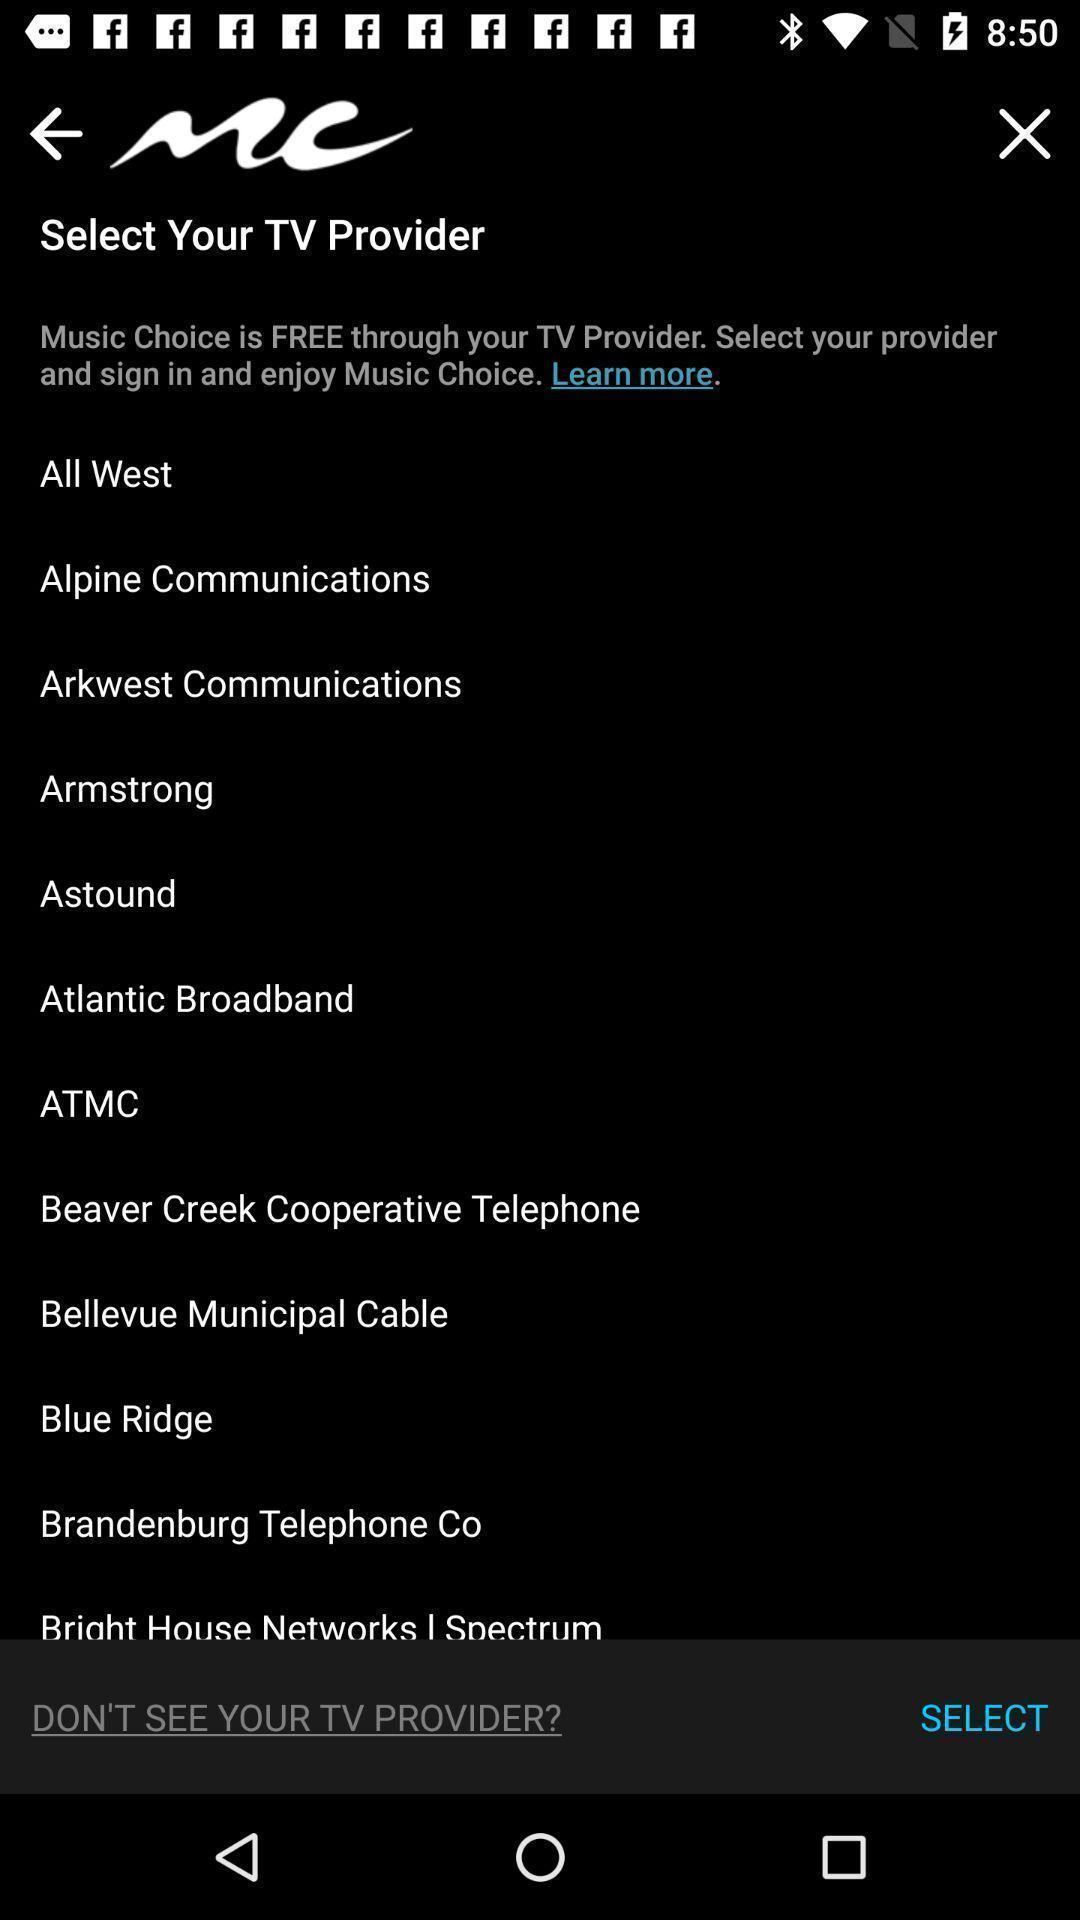Summarize the information in this screenshot. Screen displaying multiple options to select tv provider. 